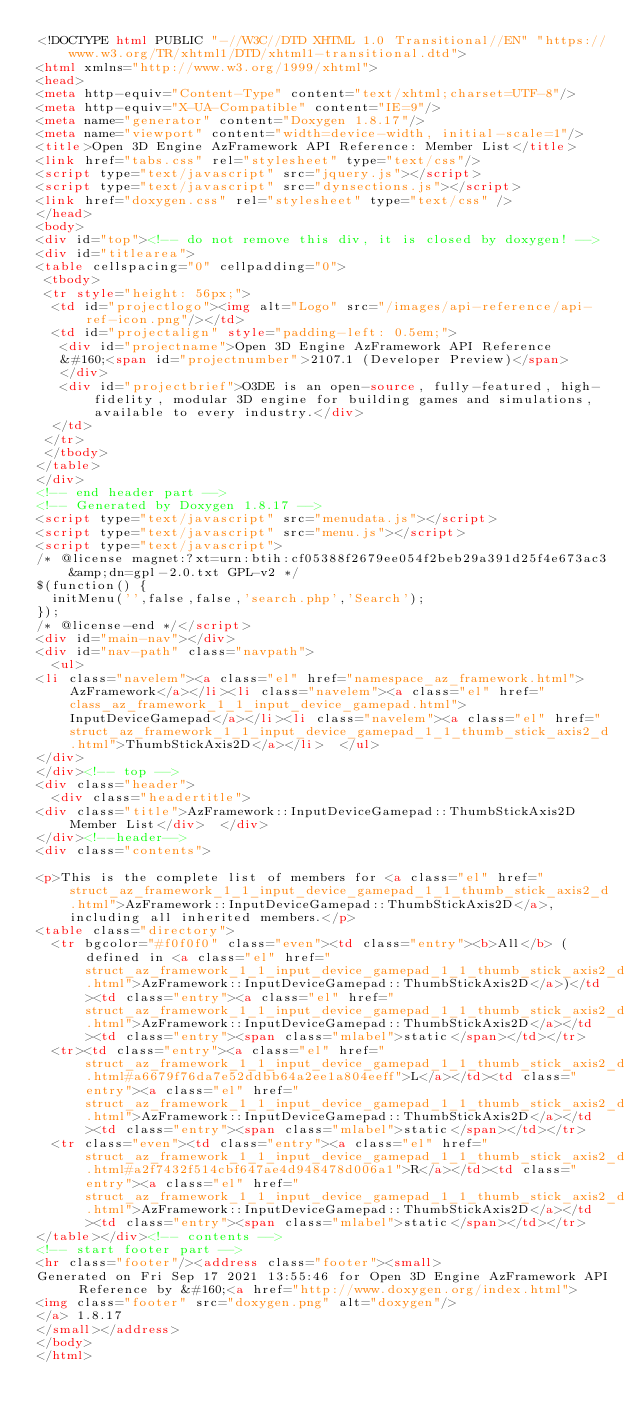Convert code to text. <code><loc_0><loc_0><loc_500><loc_500><_HTML_><!DOCTYPE html PUBLIC "-//W3C//DTD XHTML 1.0 Transitional//EN" "https://www.w3.org/TR/xhtml1/DTD/xhtml1-transitional.dtd">
<html xmlns="http://www.w3.org/1999/xhtml">
<head>
<meta http-equiv="Content-Type" content="text/xhtml;charset=UTF-8"/>
<meta http-equiv="X-UA-Compatible" content="IE=9"/>
<meta name="generator" content="Doxygen 1.8.17"/>
<meta name="viewport" content="width=device-width, initial-scale=1"/>
<title>Open 3D Engine AzFramework API Reference: Member List</title>
<link href="tabs.css" rel="stylesheet" type="text/css"/>
<script type="text/javascript" src="jquery.js"></script>
<script type="text/javascript" src="dynsections.js"></script>
<link href="doxygen.css" rel="stylesheet" type="text/css" />
</head>
<body>
<div id="top"><!-- do not remove this div, it is closed by doxygen! -->
<div id="titlearea">
<table cellspacing="0" cellpadding="0">
 <tbody>
 <tr style="height: 56px;">
  <td id="projectlogo"><img alt="Logo" src="/images/api-reference/api-ref-icon.png"/></td>
  <td id="projectalign" style="padding-left: 0.5em;">
   <div id="projectname">Open 3D Engine AzFramework API Reference
   &#160;<span id="projectnumber">2107.1 (Developer Preview)</span>
   </div>
   <div id="projectbrief">O3DE is an open-source, fully-featured, high-fidelity, modular 3D engine for building games and simulations, available to every industry.</div>
  </td>
 </tr>
 </tbody>
</table>
</div>
<!-- end header part -->
<!-- Generated by Doxygen 1.8.17 -->
<script type="text/javascript" src="menudata.js"></script>
<script type="text/javascript" src="menu.js"></script>
<script type="text/javascript">
/* @license magnet:?xt=urn:btih:cf05388f2679ee054f2beb29a391d25f4e673ac3&amp;dn=gpl-2.0.txt GPL-v2 */
$(function() {
  initMenu('',false,false,'search.php','Search');
});
/* @license-end */</script>
<div id="main-nav"></div>
<div id="nav-path" class="navpath">
  <ul>
<li class="navelem"><a class="el" href="namespace_az_framework.html">AzFramework</a></li><li class="navelem"><a class="el" href="class_az_framework_1_1_input_device_gamepad.html">InputDeviceGamepad</a></li><li class="navelem"><a class="el" href="struct_az_framework_1_1_input_device_gamepad_1_1_thumb_stick_axis2_d.html">ThumbStickAxis2D</a></li>  </ul>
</div>
</div><!-- top -->
<div class="header">
  <div class="headertitle">
<div class="title">AzFramework::InputDeviceGamepad::ThumbStickAxis2D Member List</div>  </div>
</div><!--header-->
<div class="contents">

<p>This is the complete list of members for <a class="el" href="struct_az_framework_1_1_input_device_gamepad_1_1_thumb_stick_axis2_d.html">AzFramework::InputDeviceGamepad::ThumbStickAxis2D</a>, including all inherited members.</p>
<table class="directory">
  <tr bgcolor="#f0f0f0" class="even"><td class="entry"><b>All</b> (defined in <a class="el" href="struct_az_framework_1_1_input_device_gamepad_1_1_thumb_stick_axis2_d.html">AzFramework::InputDeviceGamepad::ThumbStickAxis2D</a>)</td><td class="entry"><a class="el" href="struct_az_framework_1_1_input_device_gamepad_1_1_thumb_stick_axis2_d.html">AzFramework::InputDeviceGamepad::ThumbStickAxis2D</a></td><td class="entry"><span class="mlabel">static</span></td></tr>
  <tr><td class="entry"><a class="el" href="struct_az_framework_1_1_input_device_gamepad_1_1_thumb_stick_axis2_d.html#a6679f76da7e52ddbb64a2ee1a804eeff">L</a></td><td class="entry"><a class="el" href="struct_az_framework_1_1_input_device_gamepad_1_1_thumb_stick_axis2_d.html">AzFramework::InputDeviceGamepad::ThumbStickAxis2D</a></td><td class="entry"><span class="mlabel">static</span></td></tr>
  <tr class="even"><td class="entry"><a class="el" href="struct_az_framework_1_1_input_device_gamepad_1_1_thumb_stick_axis2_d.html#a2f7432f514cbf647ae4d948478d006a1">R</a></td><td class="entry"><a class="el" href="struct_az_framework_1_1_input_device_gamepad_1_1_thumb_stick_axis2_d.html">AzFramework::InputDeviceGamepad::ThumbStickAxis2D</a></td><td class="entry"><span class="mlabel">static</span></td></tr>
</table></div><!-- contents -->
<!-- start footer part -->
<hr class="footer"/><address class="footer"><small>
Generated on Fri Sep 17 2021 13:55:46 for Open 3D Engine AzFramework API Reference by &#160;<a href="http://www.doxygen.org/index.html">
<img class="footer" src="doxygen.png" alt="doxygen"/>
</a> 1.8.17
</small></address>
</body>
</html>
</code> 